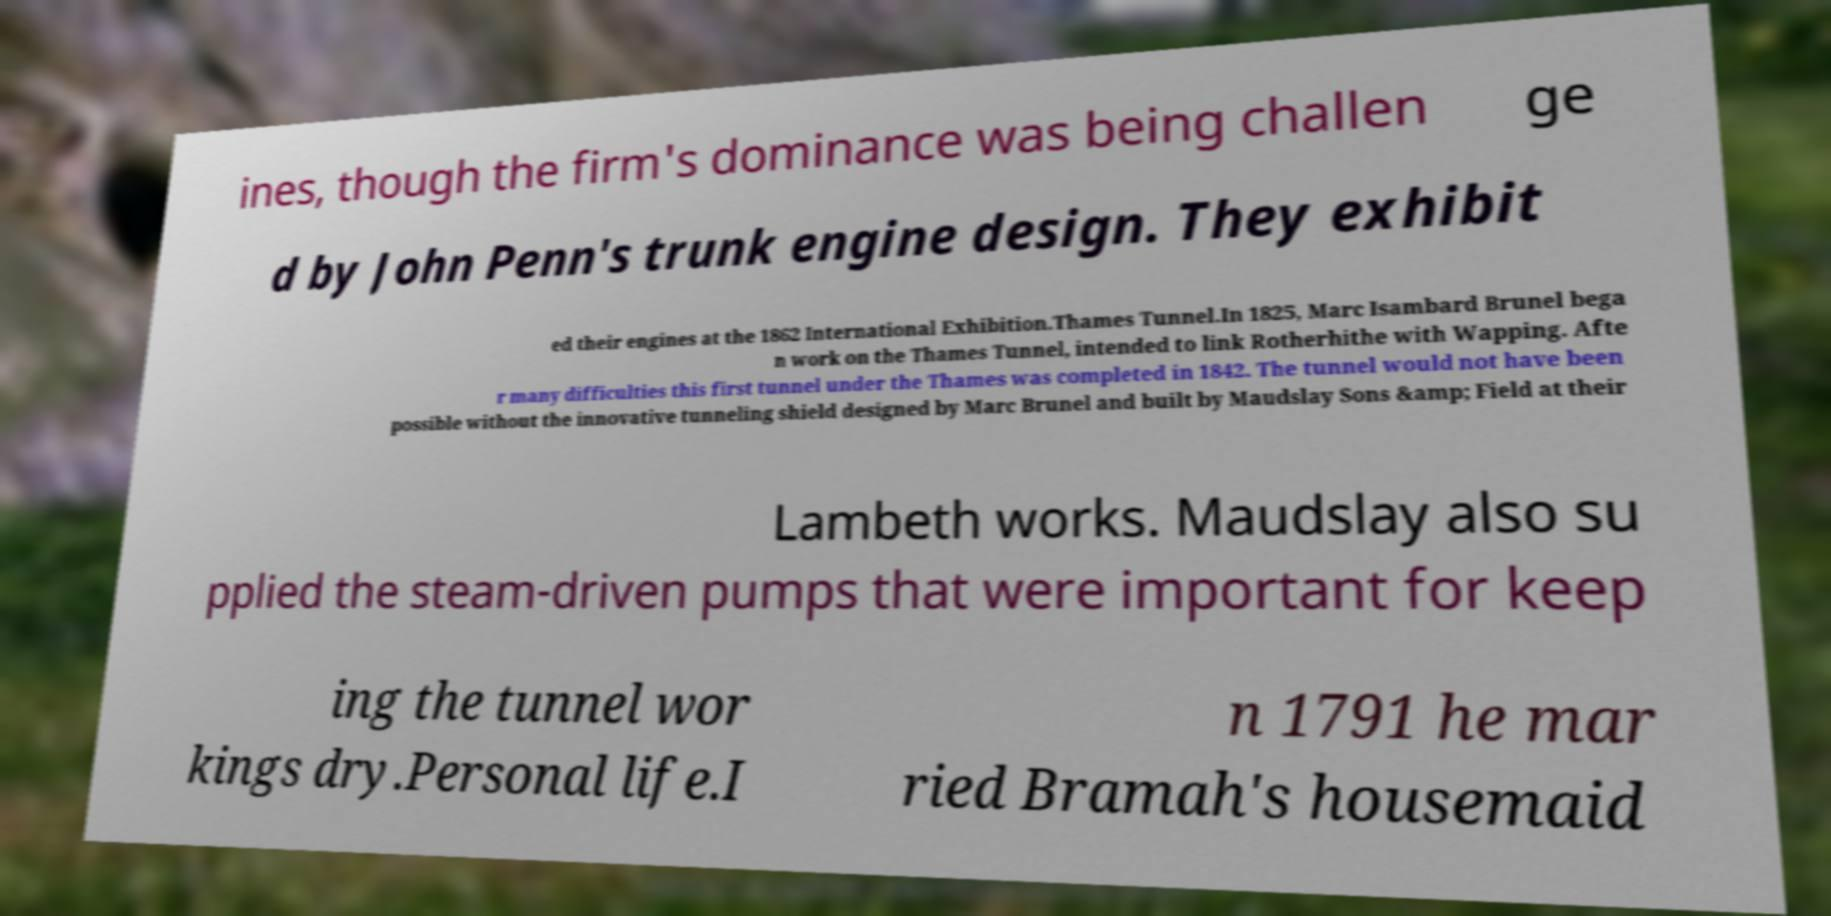Could you extract and type out the text from this image? ines, though the firm's dominance was being challen ge d by John Penn's trunk engine design. They exhibit ed their engines at the 1862 International Exhibition.Thames Tunnel.In 1825, Marc Isambard Brunel bega n work on the Thames Tunnel, intended to link Rotherhithe with Wapping. Afte r many difficulties this first tunnel under the Thames was completed in 1842. The tunnel would not have been possible without the innovative tunneling shield designed by Marc Brunel and built by Maudslay Sons &amp; Field at their Lambeth works. Maudslay also su pplied the steam-driven pumps that were important for keep ing the tunnel wor kings dry.Personal life.I n 1791 he mar ried Bramah's housemaid 